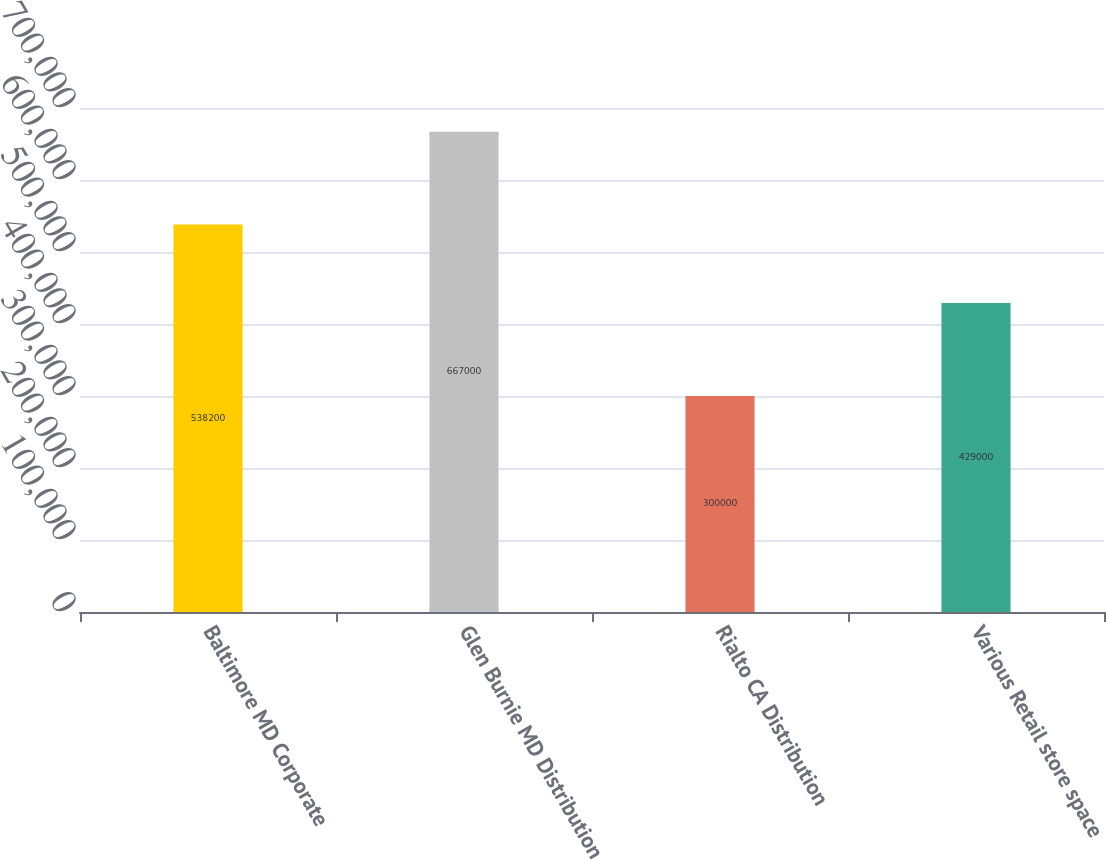Convert chart. <chart><loc_0><loc_0><loc_500><loc_500><bar_chart><fcel>Baltimore MD Corporate<fcel>Glen Burnie MD Distribution<fcel>Rialto CA Distribution<fcel>Various Retail store space<nl><fcel>538200<fcel>667000<fcel>300000<fcel>429000<nl></chart> 